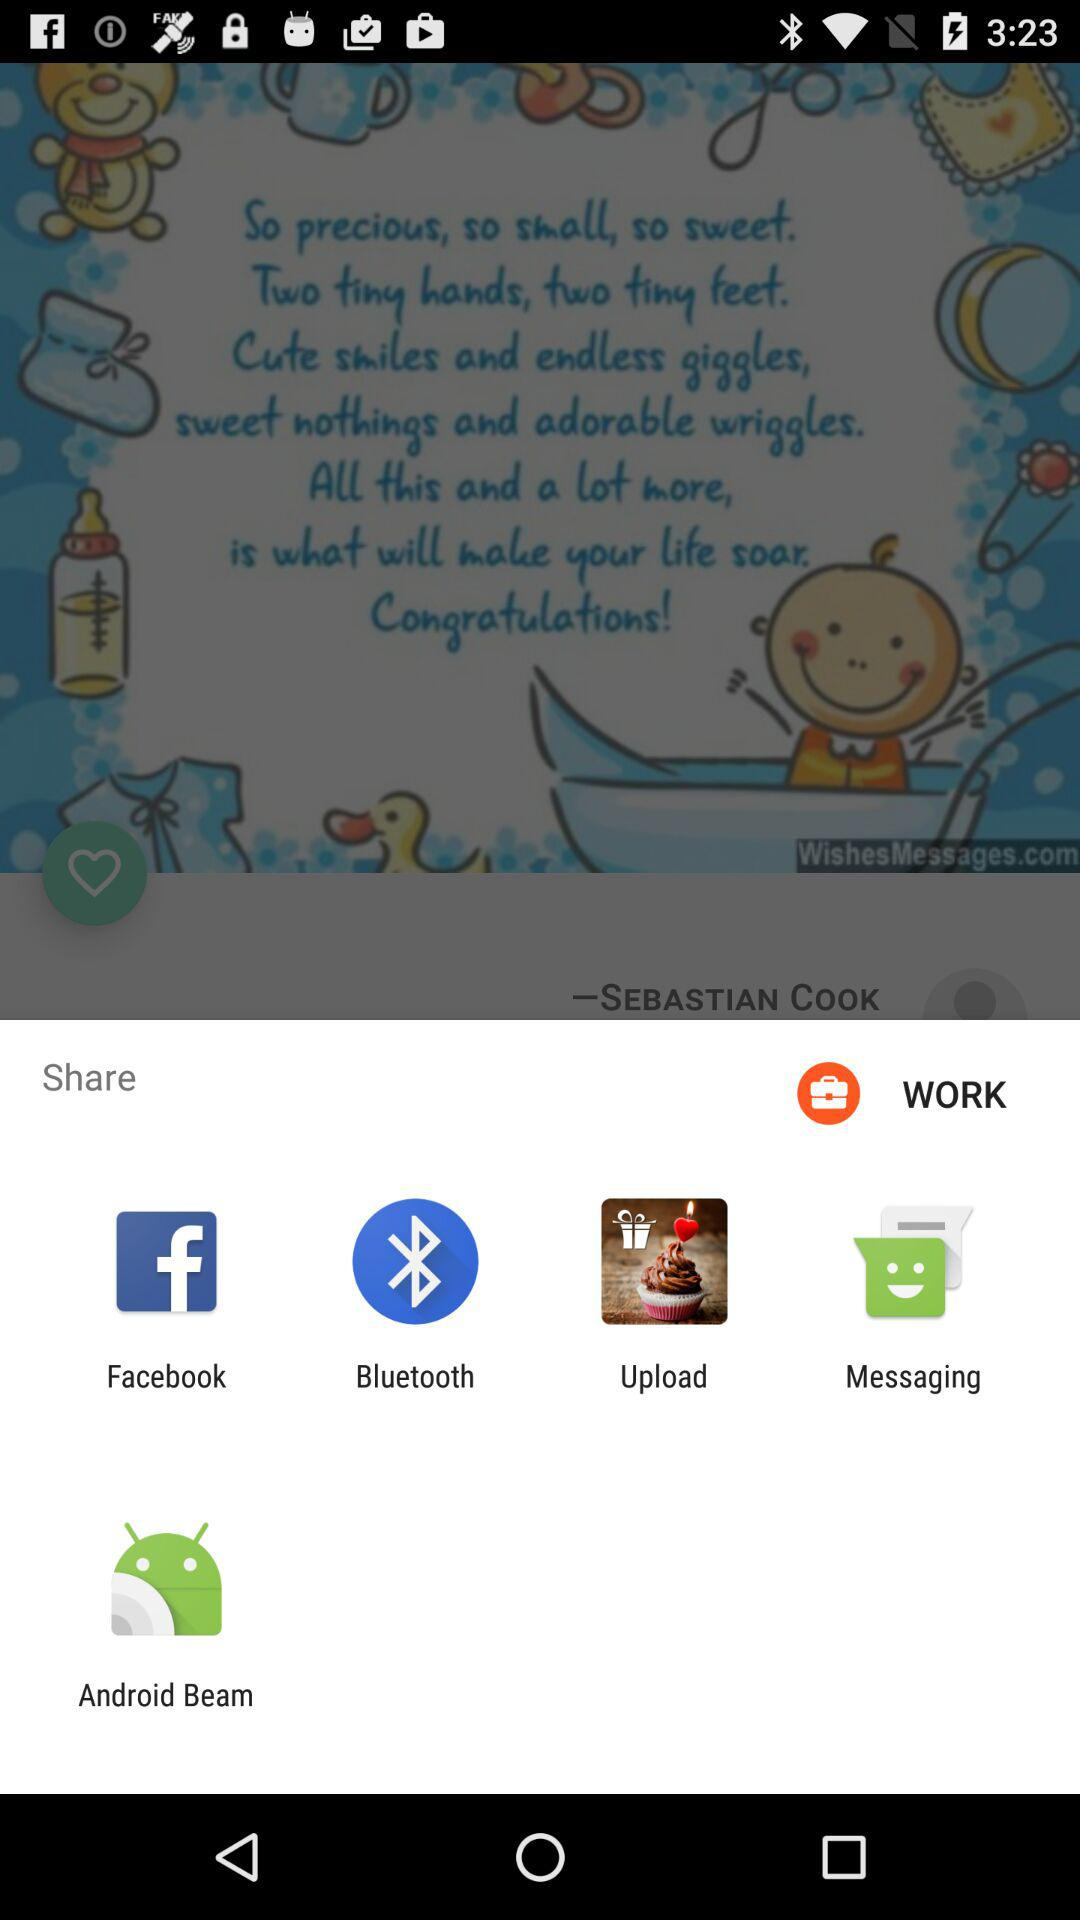Which app can we use to share the content? You can use "Facebook", "Bluetooth", "Upload", "Messaging" and "Android Beam" to share the content. 